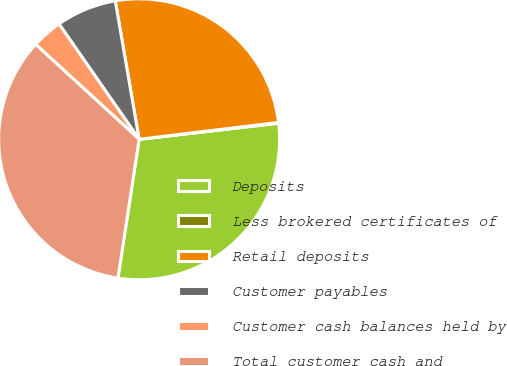Convert chart. <chart><loc_0><loc_0><loc_500><loc_500><pie_chart><fcel>Deposits<fcel>Less brokered certificates of<fcel>Retail deposits<fcel>Customer payables<fcel>Customer cash balances held by<fcel>Total customer cash and<nl><fcel>29.23%<fcel>0.09%<fcel>25.8%<fcel>6.95%<fcel>3.52%<fcel>34.4%<nl></chart> 